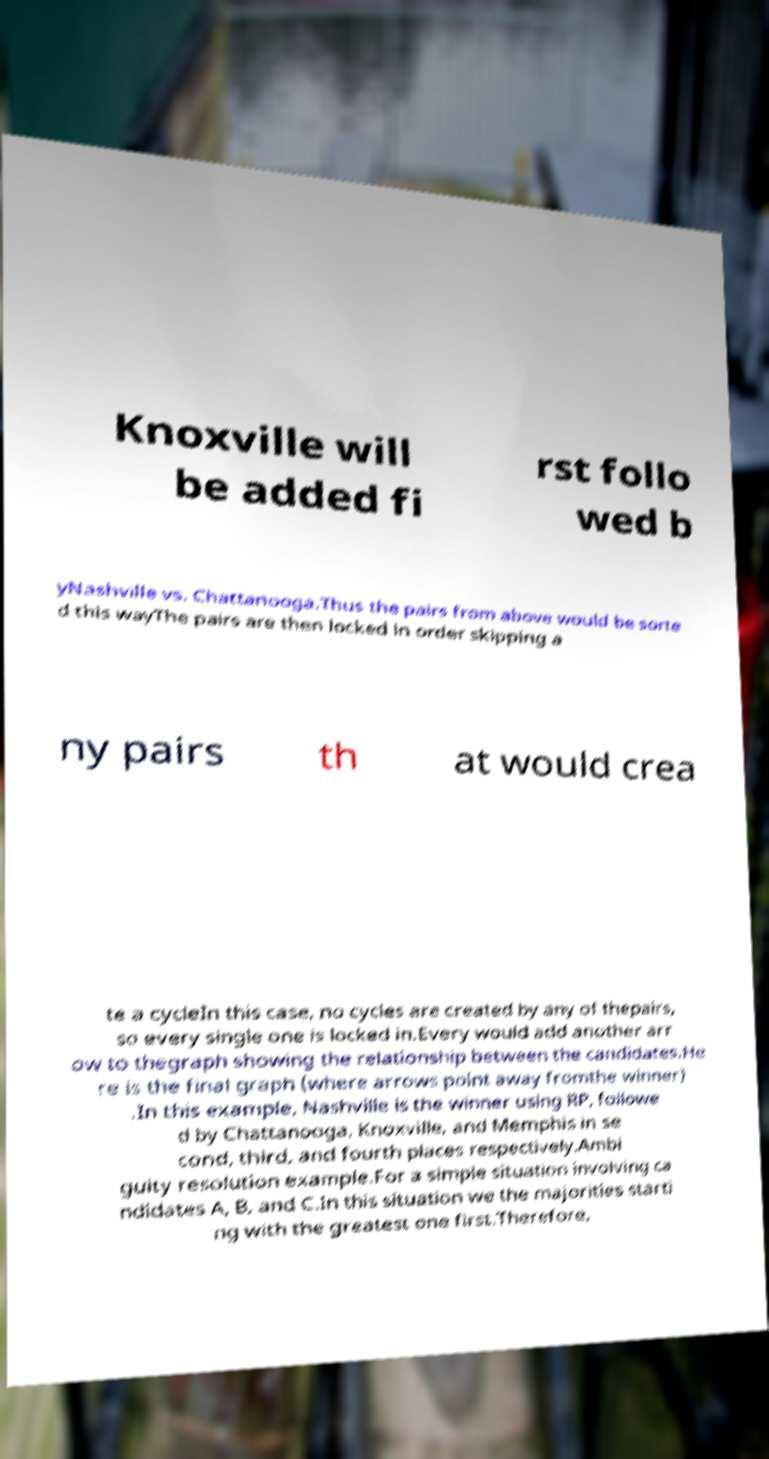Please identify and transcribe the text found in this image. Knoxville will be added fi rst follo wed b yNashville vs. Chattanooga.Thus the pairs from above would be sorte d this wayThe pairs are then locked in order skipping a ny pairs th at would crea te a cycleIn this case, no cycles are created by any of thepairs, so every single one is locked in.Every would add another arr ow to thegraph showing the relationship between the candidates.He re is the final graph (where arrows point away fromthe winner) .In this example, Nashville is the winner using RP, followe d by Chattanooga, Knoxville, and Memphis in se cond, third, and fourth places respectively.Ambi guity resolution example.For a simple situation involving ca ndidates A, B, and C.In this situation we the majorities starti ng with the greatest one first.Therefore, 